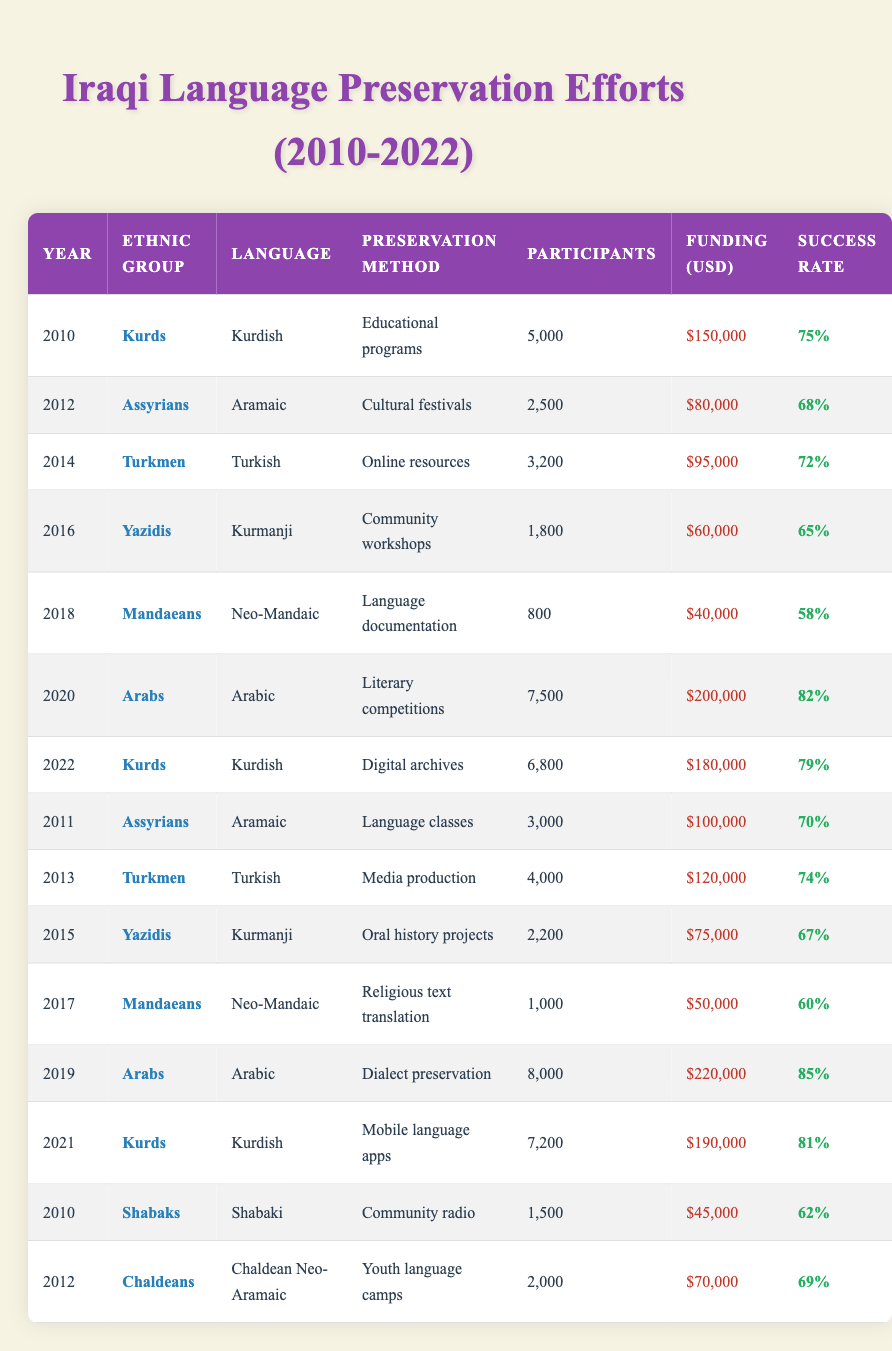What is the total funding allocated for language preservation efforts by Arabs in 2020? From the table, the funding for language preservation efforts by Arabs in 2020 is recorded as $200,000
Answer: $200,000 Which ethnic group had the highest number of participants in language preservation efforts in 2019? In 2019, the Arabs had the highest number of participants at 8,000 compared to other ethnic groups listed in that year
Answer: Arabs What was the success rate of the preservation method used by Yazidis in 2015? The success rate for the preservation method used by Yazidis in 2015 is 67%, as shown in the table
Answer: 67% Was there an increase in participants from the local methods used for Kurdish language preservation from 2010 to 2022? In 2010, there were 5,000 participants, and by 2022, the number increased to 6,800. Thus, there was an increase in participants over this period
Answer: Yes What is the average success rate of language preservation methods among Assyrians from 2011 to 2012? The success rates for Assyrians in 2011 and 2012 are 70% and 68% respectively. To find the average: (70 + 68) / 2 = 68%
Answer: 69% In which year did the Mandaeans have their lowest success rate, and what was that rate? The Mandaeans had their lowest success rate in 2018 at 58%, based on the data provided
Answer: 58% What percentage increase in funding did the Kurdish language preservation efforts see from 2010 to 2022? In 2010, funding was $150,000 and in 2022 it was $180,000. The increase in funding is $180,000 - $150,000 = $30,000. The percentage increase is ($30,000 / $150,000) * 100 = 20%
Answer: 20% How many total participants were involved in language preservation efforts across all ethnic groups in 2016? In 2016, participants were recorded as follows: Yazidis: 1,800. There are no other ethnic groups listed for that year. Therefore, the total is 1,800
Answer: 1,800 Which preservation method had the highest reported success rate, and which ethnic group used it? The highest success rate was associated with the literary competitions used by Arabs in 2020, which had a success rate of 82%
Answer: Literary competitions by Arabs 